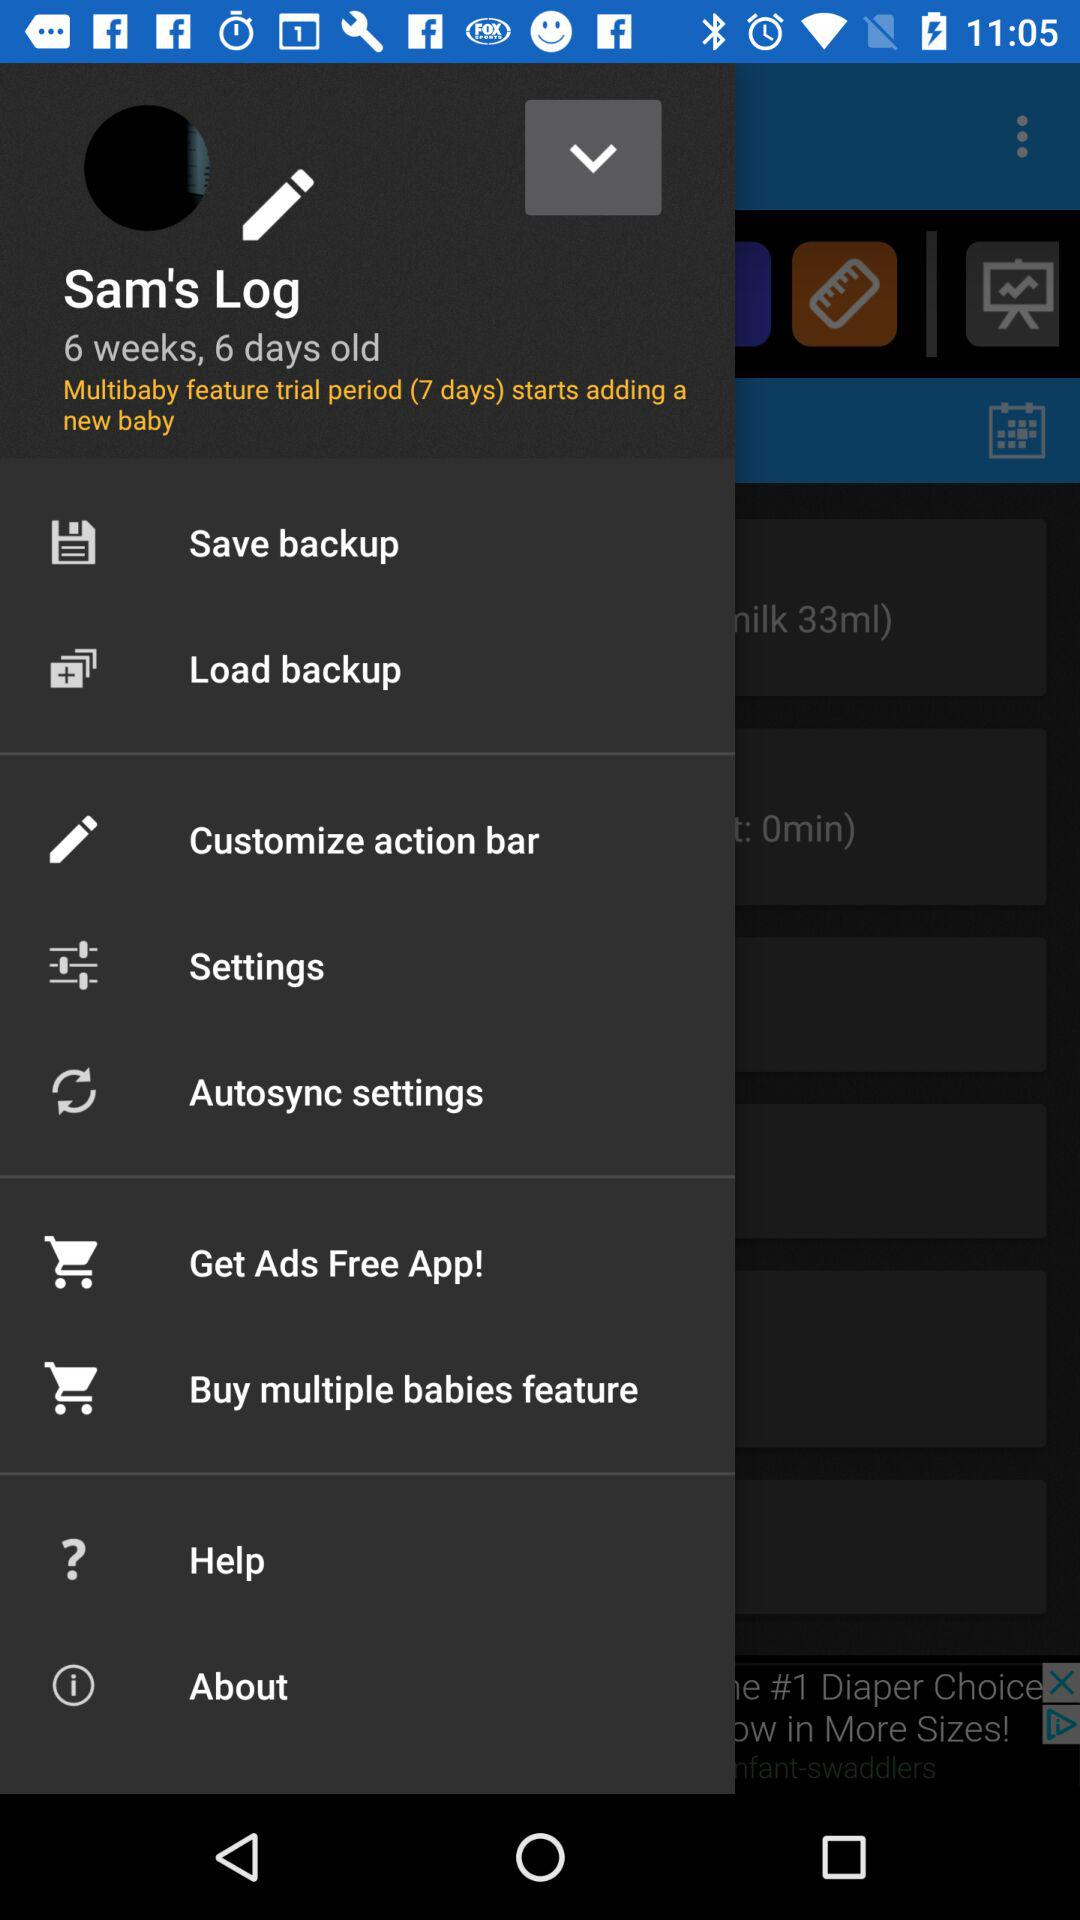How long is the multibaby feature trial period for adding a new baby? The multibaby feature trial period for adding a new baby is 7 days long. 